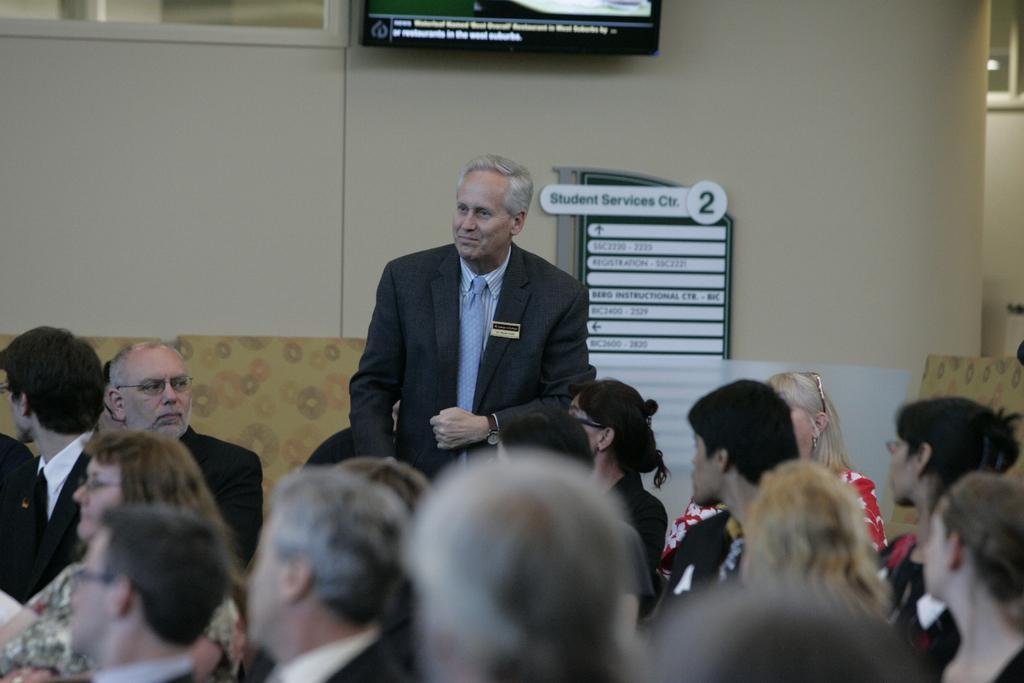Please provide a concise description of this image. In this picture we can see a group of people where a man wore a blazer and a tie and standing and smiling and in the background we can see a television, name boards, wall. 